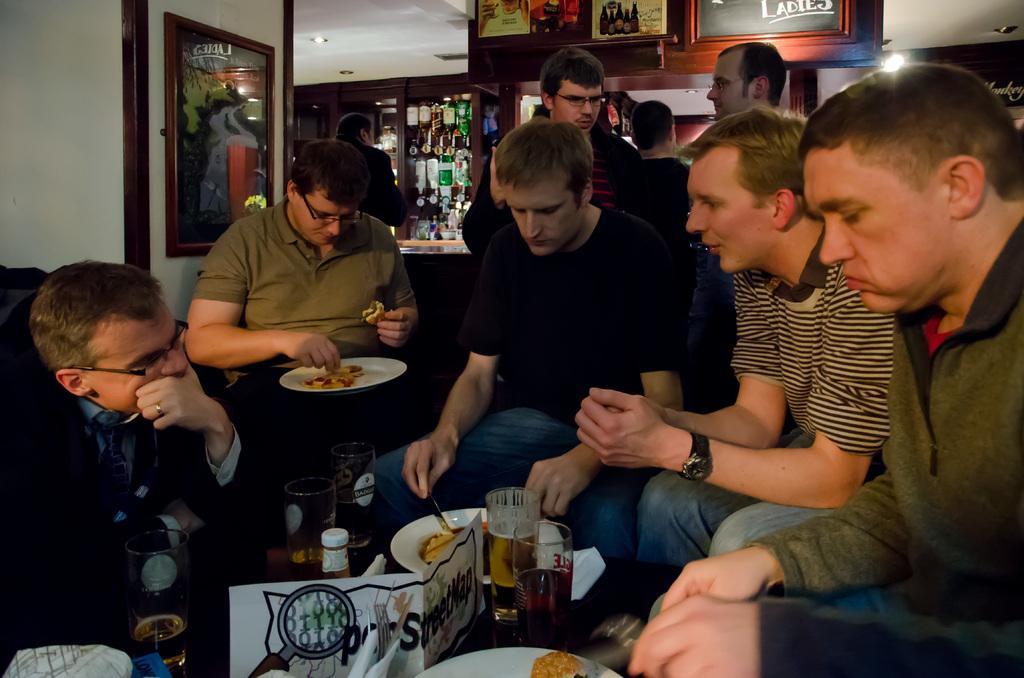Please provide a concise description of this image. In this image we can some group of persons sitting on couch and some are standing, in the foreground of the image we can see a table on which there are some bottles, glasses, plates and some other items and in the background of the image there are some bottles arranged in shelves and some paintings attached to the wall. 